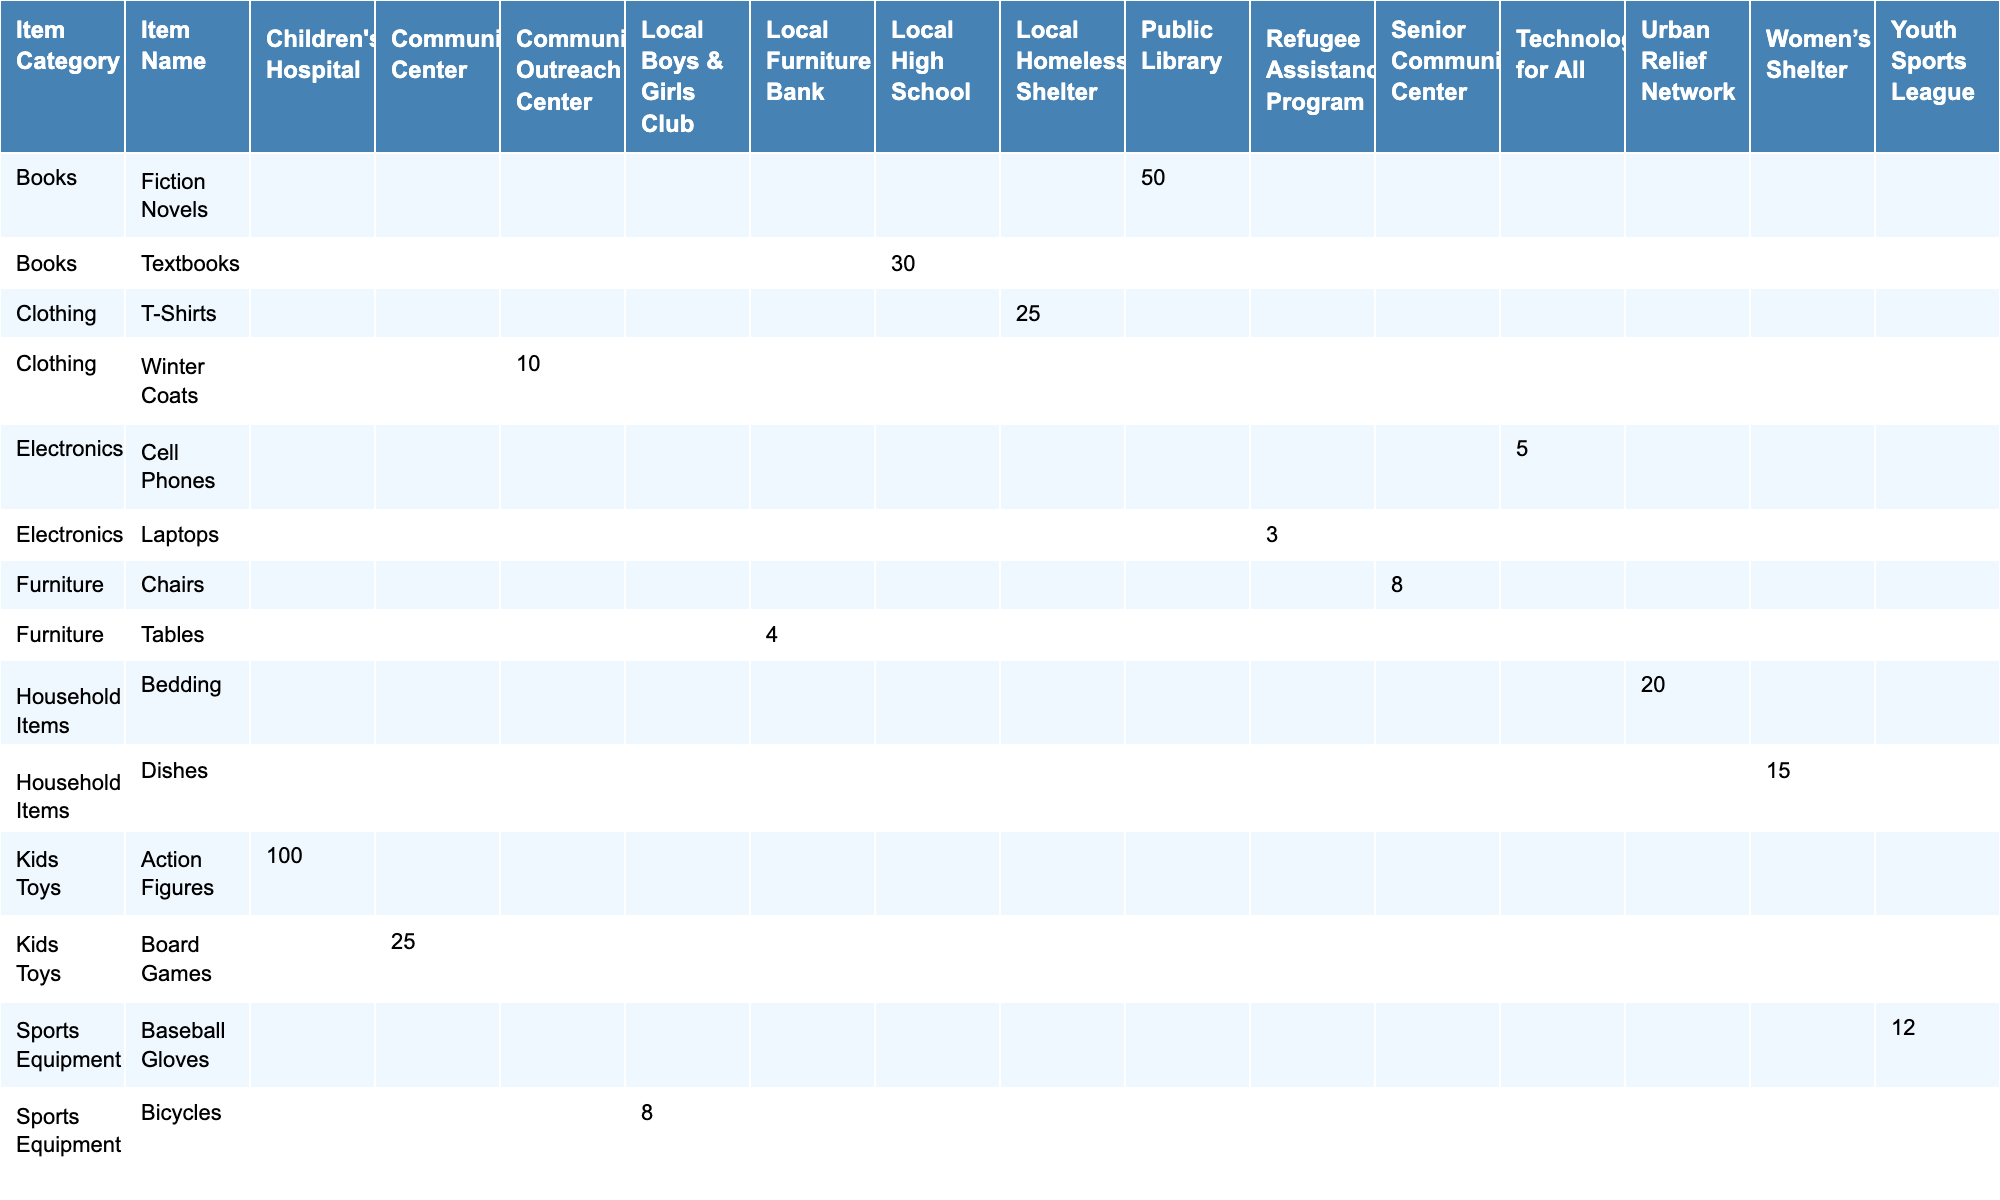What items were donated to the Local Homeless Shelter? Referring to the table, the Local Homeless Shelter received 25 T-Shirts as a donation.
Answer: T-Shirts How many items of clothing were donated in total? The clothing items donated are T-Shirts (25) and Winter Coats (10). Adding these gives 25 + 10 = 35 clothing items.
Answer: 35 Which donation destination received the most kids toys? The table shows that the Children's Hospital received 100 Action Figures, which is more than any other destination for kids toys.
Answer: Children's Hospital Did the Senior Community Center receive any furniture? From the table, it shows that the Senior Community Center received 8 Chairs as a donation, confirming they received furniture.
Answer: Yes What is the total quantity of electronics donated? The total quantity of electronics consists of Cell Phones (5) and Laptops (3). Adding these yields 5 + 3 = 8 electronics donated.
Answer: 8 Which item category had the least quantity donated? The categories are Clothing (35), Books (80), Household Items (35), Electronics (8), Kids Toys (125), Sports Equipment (20), and Furniture (12). The category with the least quantity is Electronics at 8.
Answer: Electronics How many different donation destinations were involved in the donations recorded? The distinct donation destinations listed are Local Homeless Shelter, Community Outreach Center, Public Library, Local High School, Women’s Shelter, Urban Relief Network, Technology for All, Refugee Assistance Program, Children's Hospital, Community Center, Local Boys & Girls Club, Youth Sports League, Local Furniture Bank, and Senior Community Center, totaling 14 unique destinations.
Answer: 14 What was the total quantity of sports equipment donated? The sports equipment items donated include Bicycles (8) and Baseball Gloves (12). Together, 8 + 12 gives a total of 20 sports equipment items donated.
Answer: 20 Which item from the Household Items category was donated to the Urban Relief Network? The table indicates that Bedding was donated to the Urban Relief Network, confirming it as the item from the Household Items category sent there.
Answer: Bedding What is the total number of books donated to the Public Library and the Local High School combined? The totals for the Public Library (Fiction Novels: 50) and Local High School (Textbooks: 30) when added give 50 + 30 = 80 books in total.
Answer: 80 